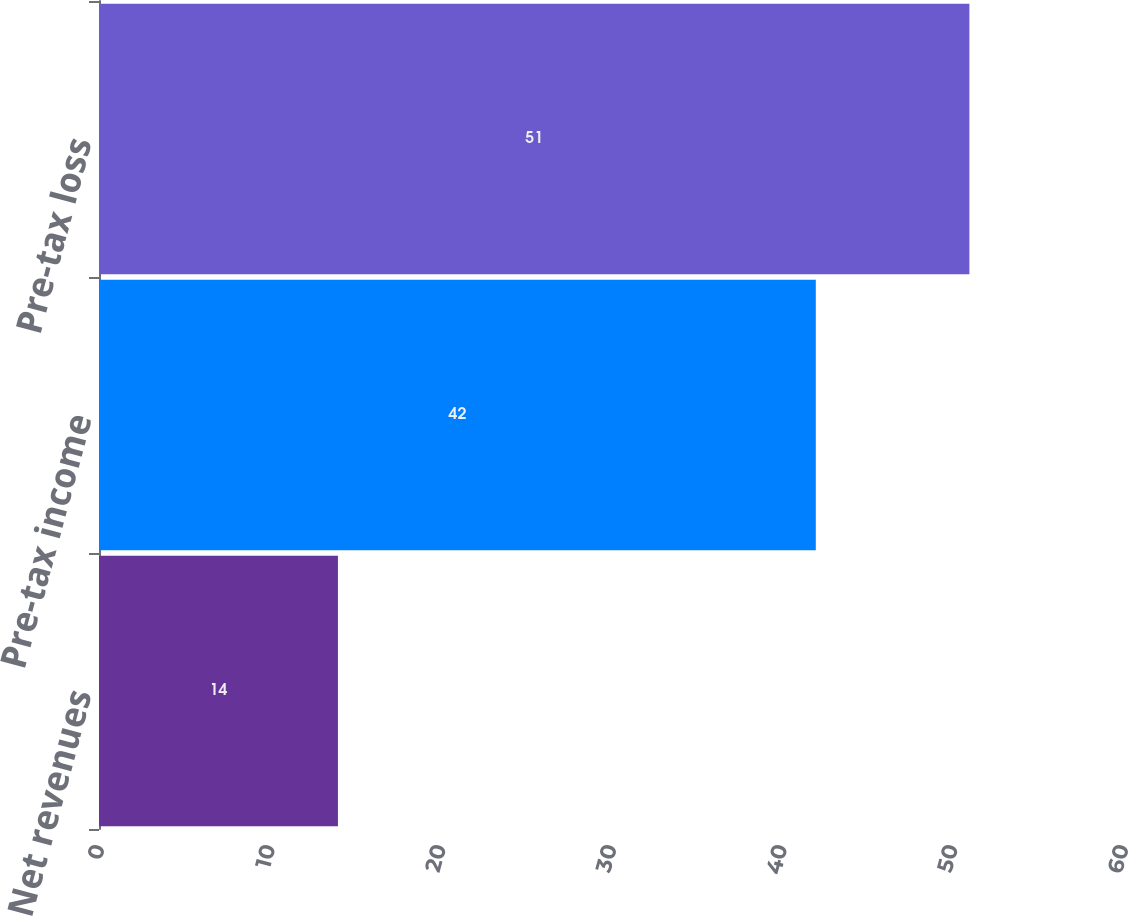<chart> <loc_0><loc_0><loc_500><loc_500><bar_chart><fcel>Net revenues<fcel>Pre-tax income<fcel>Pre-tax loss<nl><fcel>14<fcel>42<fcel>51<nl></chart> 